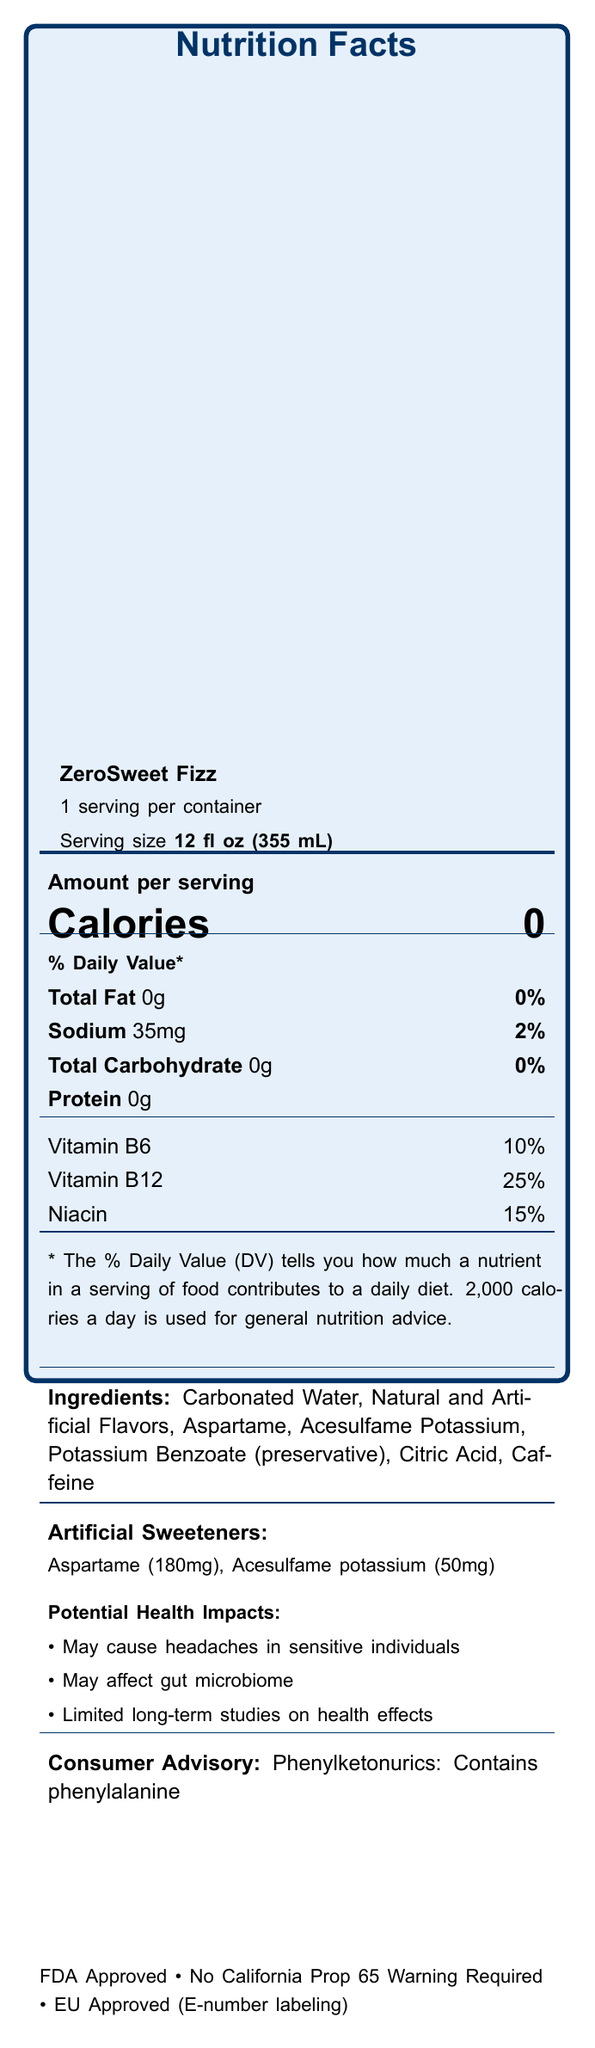what is the serving size of ZeroSweet Fizz? The serving size is clearly mentioned at the top portion of the document under "Serving size."
Answer: 12 fl oz (355 mL) How much sodium is in one serving of ZeroSweet Fizz? The sodium content is listed under the nutritional information as "Sodium 35mg."
Answer: 35mg What are the artificial sweeteners used in ZeroSweet Fizz? The ingredients list and artificial sweeteners section clearly mention the use of Aspartame and Acesulfame potassium.
Answer: Aspartame and Acesulfame potassium Is ZeroSweet Fizz approved by the FDA? The document includes a statement at the bottom confirming FDA approval.
Answer: Yes What is the calorie content per serving of ZeroSweet Fizz? The calorie content is prominently displayed as "Calories 0."
Answer: 0 calories Does the product contain any proteins? The protein content is listed as "Protein 0g."
Answer: No Which of the following is a potential health impact of Aspartame? A. Weight gain B. Headaches C. Allergic reactions The document lists "May cause headaches in sensitive individuals" as one of the potential health impacts of Aspartame.
Answer: B. Headaches What vitamins are included in ZeroSweet Fizz? A. Vitamin A, Vitamin C, Calcium B. Vitamin B6, Vitamin B12, Niacin C. Vitamin D, Vitamin E, Iron D. Vitamin K, Folate, Magnesium The vitamins and minerals section lists Vitamin B6, Vitamin B12, and Niacin.
Answer: B. Vitamin B6, Vitamin B12, Niacin Does the product contain any elements that might affect individuals with phenylketonuria (PKU)? The document has a consumer advisory stating "Phenylketonurics: Contains phenylalanine," indicating it contains Aspartame which is not suitable for people with PKU.
Answer: Yes Summarize the main nutritional and health information of ZeroSweet Fizz. The document provides detailed nutritional information, ingredients, potential health impacts of artificial sweeteners, regulatory status, and a consumer advisory.
Answer: ZeroSweet Fizz is a sugar-free beverage with 0 calories per serving. It contains artificial sweeteners like Aspartame and Acesulfame potassium, with potential health impacts including headaches and effects on the gut microbiome. The product includes vitamins B6, B12, and Niacin. It's FDA approved and considered safe, but not for individuals with PKU. What is the total carbohydrate content in a single serving of ZeroSweet Fizz? The total carbohydrate content is listed as "Total Carbohydrate 0g."
Answer: 0g What are the potential health impacts of Acesulfame potassium? The document lists these potential health impacts under the artificial sweeteners section.
Answer: May affect gut microbiome, Limited long-term studies on health effects, Generally recognized as safe by FDA Is the product suitable for diabetics? The marketing claims section includes "Diabetic-friendly," indicating suitability for diabetics.
Answer: Yes How many servings are in one container of ZeroSweet Fizz? The document states "1 serving per container."
Answer: 1 What is the amount of Aspartame used per serving in ZeroSweet Fizz? The document lists the amount of Aspartame used per serving under the artificial sweeteners section.
Answer: 180mg What are the exact ingredients listed for ZeroSweet Fizz? The ingredients section provides this detailed list.
Answer: Carbonated Water, Natural and Artificial Flavors, Aspartame, Acesulfame Potassium, Potassium Benzoate (preservative), Citric Acid, Caffeine Which of the following is NOT a stated marketing claim of ZeroSweet Fizz? A. Zero calories B. Sugar-free C. Contains real fruit juice D. Diabetic-friendly The document does not list "Contains real fruit juice" as a marketing claim.
Answer: C. Contains real fruit juice Can we conclude from the document that ZeroSweet Fizz supports weight loss? The document mentions potential impacts on dental health and obesity rates but does not provide specific details or studies supporting weight loss.
Answer: Not enough information Does ZeroSweet Fizz require a California Prop 65 warning? The document specifies "California Prop 65 Warning: Not required."
Answer: No 